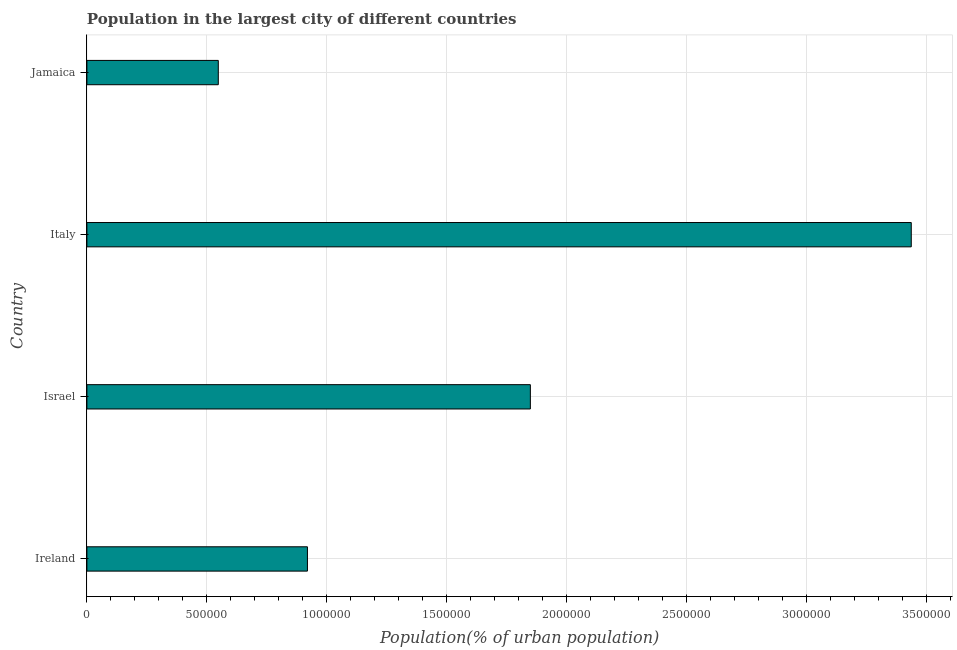Does the graph contain grids?
Your response must be concise. Yes. What is the title of the graph?
Provide a succinct answer. Population in the largest city of different countries. What is the label or title of the X-axis?
Provide a short and direct response. Population(% of urban population). What is the label or title of the Y-axis?
Your answer should be compact. Country. What is the population in largest city in Israel?
Your response must be concise. 1.85e+06. Across all countries, what is the maximum population in largest city?
Provide a short and direct response. 3.44e+06. Across all countries, what is the minimum population in largest city?
Provide a succinct answer. 5.48e+05. In which country was the population in largest city minimum?
Your response must be concise. Jamaica. What is the sum of the population in largest city?
Your response must be concise. 6.75e+06. What is the difference between the population in largest city in Ireland and Jamaica?
Provide a short and direct response. 3.72e+05. What is the average population in largest city per country?
Make the answer very short. 1.69e+06. What is the median population in largest city?
Your answer should be compact. 1.38e+06. What is the ratio of the population in largest city in Ireland to that in Italy?
Offer a terse response. 0.27. Is the population in largest city in Israel less than that in Jamaica?
Ensure brevity in your answer.  No. Is the difference between the population in largest city in Israel and Jamaica greater than the difference between any two countries?
Keep it short and to the point. No. What is the difference between the highest and the second highest population in largest city?
Offer a terse response. 1.59e+06. Is the sum of the population in largest city in Israel and Italy greater than the maximum population in largest city across all countries?
Offer a terse response. Yes. What is the difference between the highest and the lowest population in largest city?
Ensure brevity in your answer.  2.89e+06. How many bars are there?
Make the answer very short. 4. Are all the bars in the graph horizontal?
Provide a succinct answer. Yes. How many countries are there in the graph?
Provide a succinct answer. 4. What is the difference between two consecutive major ticks on the X-axis?
Ensure brevity in your answer.  5.00e+05. What is the Population(% of urban population) of Ireland?
Ensure brevity in your answer.  9.20e+05. What is the Population(% of urban population) of Israel?
Offer a very short reply. 1.85e+06. What is the Population(% of urban population) in Italy?
Your answer should be very brief. 3.44e+06. What is the Population(% of urban population) of Jamaica?
Your response must be concise. 5.48e+05. What is the difference between the Population(% of urban population) in Ireland and Israel?
Keep it short and to the point. -9.30e+05. What is the difference between the Population(% of urban population) in Ireland and Italy?
Ensure brevity in your answer.  -2.52e+06. What is the difference between the Population(% of urban population) in Ireland and Jamaica?
Provide a short and direct response. 3.72e+05. What is the difference between the Population(% of urban population) in Israel and Italy?
Your answer should be compact. -1.59e+06. What is the difference between the Population(% of urban population) in Israel and Jamaica?
Keep it short and to the point. 1.30e+06. What is the difference between the Population(% of urban population) in Italy and Jamaica?
Give a very brief answer. 2.89e+06. What is the ratio of the Population(% of urban population) in Ireland to that in Israel?
Provide a succinct answer. 0.5. What is the ratio of the Population(% of urban population) in Ireland to that in Italy?
Your response must be concise. 0.27. What is the ratio of the Population(% of urban population) in Ireland to that in Jamaica?
Give a very brief answer. 1.68. What is the ratio of the Population(% of urban population) in Israel to that in Italy?
Offer a terse response. 0.54. What is the ratio of the Population(% of urban population) in Israel to that in Jamaica?
Provide a short and direct response. 3.38. What is the ratio of the Population(% of urban population) in Italy to that in Jamaica?
Provide a short and direct response. 6.27. 